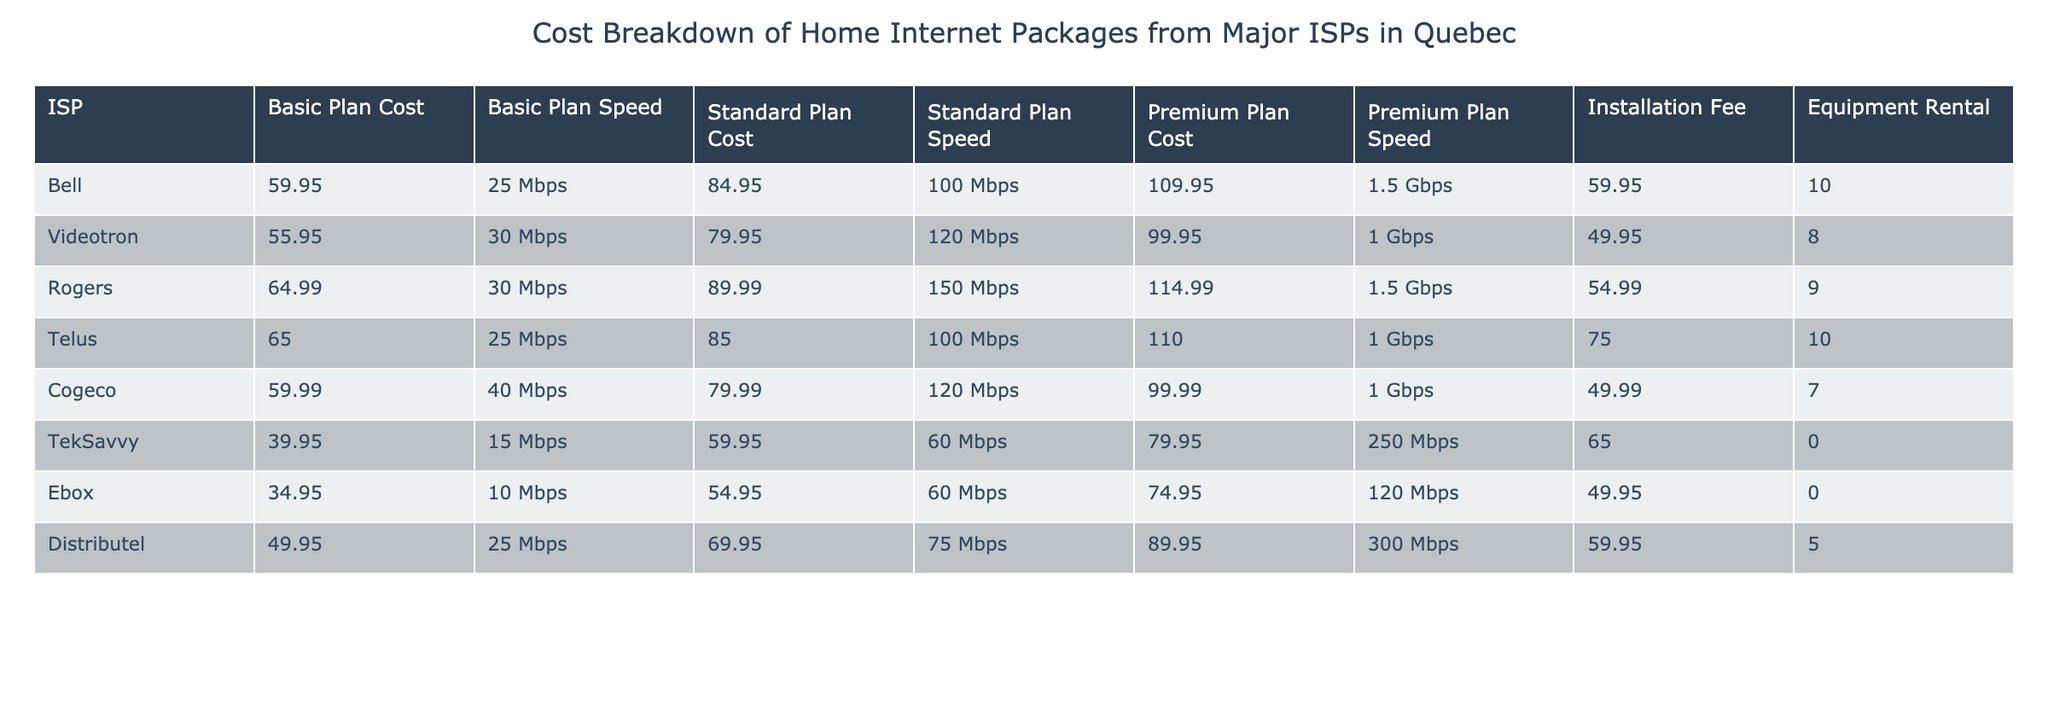What is the cost of the Basic plan from Ebox? The table shows that the Basic Plan Cost from Ebox is listed as 34.95.
Answer: 34.95 Which ISP has the highest Installation Fee? By comparing the Installation Fees listed in the table, Telus has the highest fee at 75.00.
Answer: 75.00 What is the speed of the Premium plan from Cogeco? The table indicates that the Premium Plan Speed from Cogeco is 1 Gbps.
Answer: 1 Gbps Which ISP offers the lowest Standard Plan Cost? The table shows that TekSavvy offers the lowest Standard Plan Cost at 59.95.
Answer: 59.95 If I choose the Premium plan from Rogers, what will I pay monthly in total, including the equipment rental? The Premium plan cost from Rogers is 114.99 and the equipment rental is 9.00, so total monthly cost is 114.99 + 9.00 = 123.99.
Answer: 123.99 Is the Basic plan from Bell cheaper than the Basic plan from Videotron? The Basic plan from Bell costs 59.95, while Videotron's Basic plan costs 55.95; since 59.95 is greater than 55.95, the statement is false.
Answer: No What’s the average cost of the Basic plan across all ISPs? The Basic plan costs are: 59.95, 55.95, 64.99, 65.00, 59.99, 39.95, 34.95, 49.95. Sum them: 59.95 + 55.95 + 64.99 + 65.00 + 59.99 + 39.95 + 34.95 + 49.95 = 495.73, and dividing by 8 gives an average of 61.96.
Answer: 61.96 What is the difference in speed between the Standard and Premium plans from TekSavvy? The Standard Plan Speed from TekSavvy is 60 Mbps, and the Premium Plan Speed is 250 Mbps. The difference is 250 - 60 = 190 Mbps.
Answer: 190 Mbps Is there any ISP that provides an equipment rental fee of zero? According to the table, TekSavvy and Ebox both have an equipment rental fee of 0.00, confirming that this statement is true.
Answer: Yes 